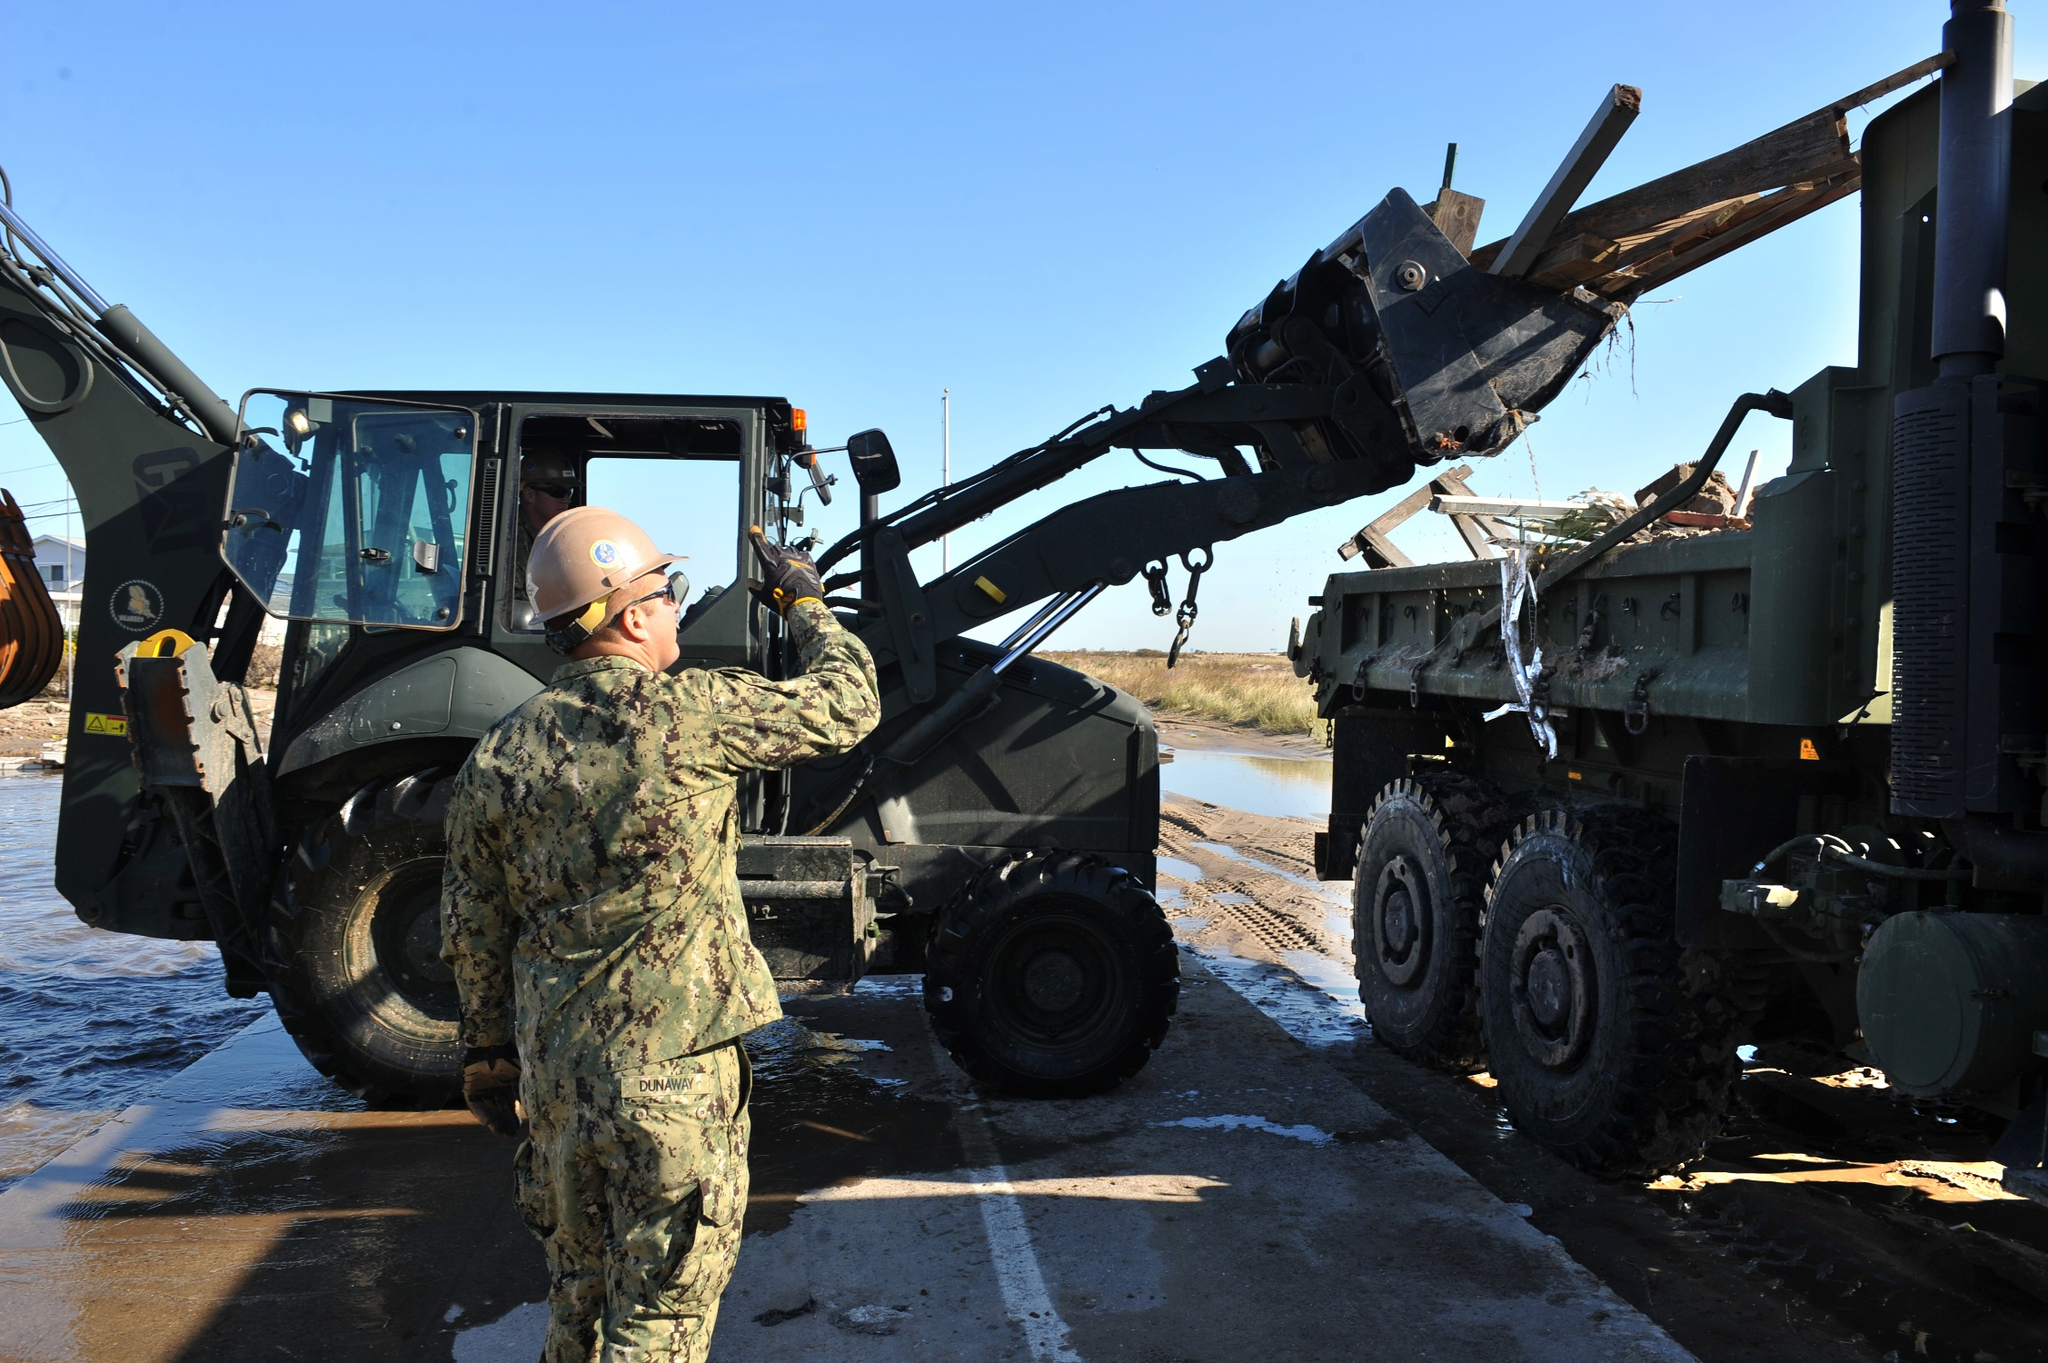Create a very creative story that is far from realistic about what’s happening in this scene. In a parallel universe, this image depicts a team of intergalactic engineers working under Earth’s sky to construct a gateway to other dimensions. The forklift is a highly advanced piece of technology disguised as normal Earth equipment, emitting subtle energy waves that align the wooden beams into a celestial pattern. The worker, a guardian from a distant galaxy, wears a suit that appears to resemble Earth's military uniform but is actually a suit of cosmic armor designed for both protection and interface with multidimensional energy fields. The serene body of water nearby is not just a lake but a portal that reflects the still waters of spatial dimensions beyond human comprehension. As the sunlight reflects off the beams, it activates hidden runes inscribed in them, commencing the creation of a timeless bridge between worlds. 